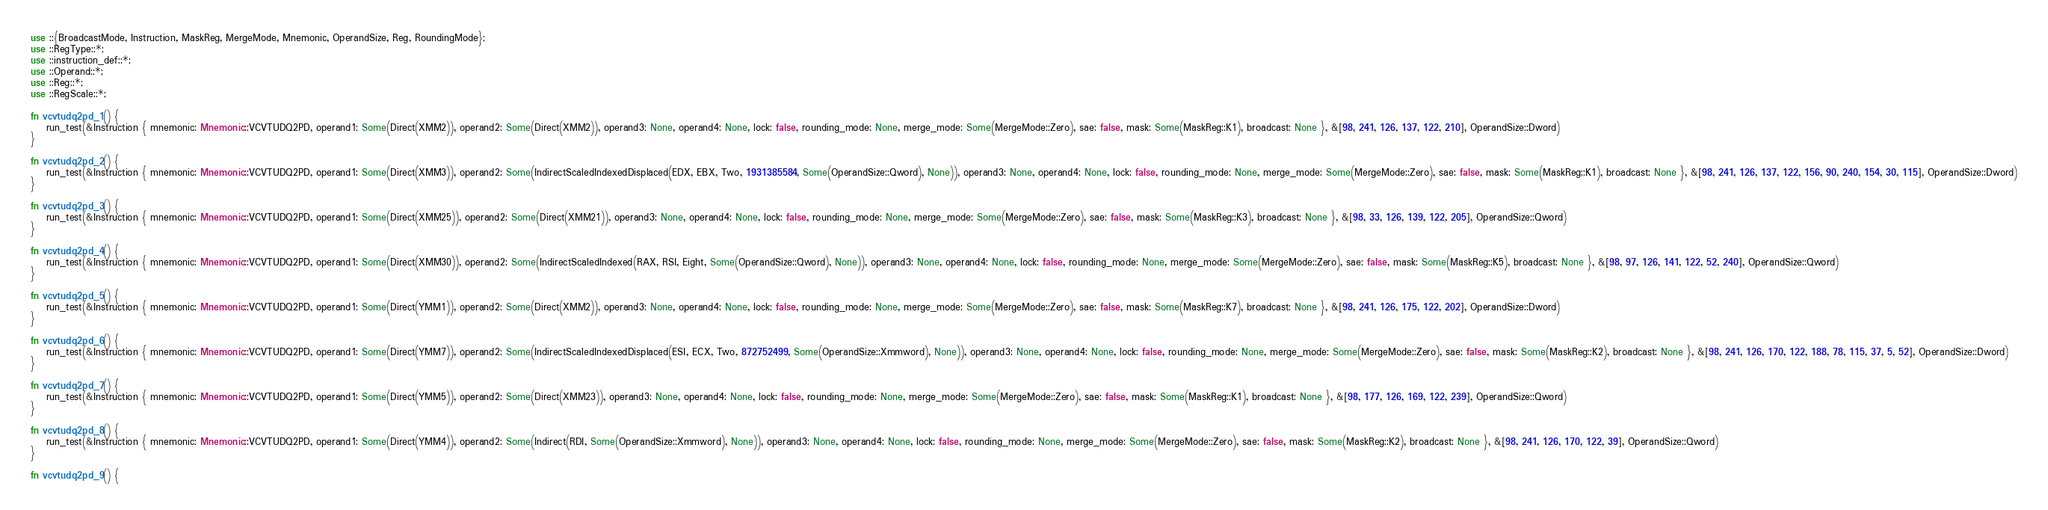Convert code to text. <code><loc_0><loc_0><loc_500><loc_500><_Rust_>use ::{BroadcastMode, Instruction, MaskReg, MergeMode, Mnemonic, OperandSize, Reg, RoundingMode};
use ::RegType::*;
use ::instruction_def::*;
use ::Operand::*;
use ::Reg::*;
use ::RegScale::*;

fn vcvtudq2pd_1() {
    run_test(&Instruction { mnemonic: Mnemonic::VCVTUDQ2PD, operand1: Some(Direct(XMM2)), operand2: Some(Direct(XMM2)), operand3: None, operand4: None, lock: false, rounding_mode: None, merge_mode: Some(MergeMode::Zero), sae: false, mask: Some(MaskReg::K1), broadcast: None }, &[98, 241, 126, 137, 122, 210], OperandSize::Dword)
}

fn vcvtudq2pd_2() {
    run_test(&Instruction { mnemonic: Mnemonic::VCVTUDQ2PD, operand1: Some(Direct(XMM3)), operand2: Some(IndirectScaledIndexedDisplaced(EDX, EBX, Two, 1931385584, Some(OperandSize::Qword), None)), operand3: None, operand4: None, lock: false, rounding_mode: None, merge_mode: Some(MergeMode::Zero), sae: false, mask: Some(MaskReg::K1), broadcast: None }, &[98, 241, 126, 137, 122, 156, 90, 240, 154, 30, 115], OperandSize::Dword)
}

fn vcvtudq2pd_3() {
    run_test(&Instruction { mnemonic: Mnemonic::VCVTUDQ2PD, operand1: Some(Direct(XMM25)), operand2: Some(Direct(XMM21)), operand3: None, operand4: None, lock: false, rounding_mode: None, merge_mode: Some(MergeMode::Zero), sae: false, mask: Some(MaskReg::K3), broadcast: None }, &[98, 33, 126, 139, 122, 205], OperandSize::Qword)
}

fn vcvtudq2pd_4() {
    run_test(&Instruction { mnemonic: Mnemonic::VCVTUDQ2PD, operand1: Some(Direct(XMM30)), operand2: Some(IndirectScaledIndexed(RAX, RSI, Eight, Some(OperandSize::Qword), None)), operand3: None, operand4: None, lock: false, rounding_mode: None, merge_mode: Some(MergeMode::Zero), sae: false, mask: Some(MaskReg::K5), broadcast: None }, &[98, 97, 126, 141, 122, 52, 240], OperandSize::Qword)
}

fn vcvtudq2pd_5() {
    run_test(&Instruction { mnemonic: Mnemonic::VCVTUDQ2PD, operand1: Some(Direct(YMM1)), operand2: Some(Direct(XMM2)), operand3: None, operand4: None, lock: false, rounding_mode: None, merge_mode: Some(MergeMode::Zero), sae: false, mask: Some(MaskReg::K7), broadcast: None }, &[98, 241, 126, 175, 122, 202], OperandSize::Dword)
}

fn vcvtudq2pd_6() {
    run_test(&Instruction { mnemonic: Mnemonic::VCVTUDQ2PD, operand1: Some(Direct(YMM7)), operand2: Some(IndirectScaledIndexedDisplaced(ESI, ECX, Two, 872752499, Some(OperandSize::Xmmword), None)), operand3: None, operand4: None, lock: false, rounding_mode: None, merge_mode: Some(MergeMode::Zero), sae: false, mask: Some(MaskReg::K2), broadcast: None }, &[98, 241, 126, 170, 122, 188, 78, 115, 37, 5, 52], OperandSize::Dword)
}

fn vcvtudq2pd_7() {
    run_test(&Instruction { mnemonic: Mnemonic::VCVTUDQ2PD, operand1: Some(Direct(YMM5)), operand2: Some(Direct(XMM23)), operand3: None, operand4: None, lock: false, rounding_mode: None, merge_mode: Some(MergeMode::Zero), sae: false, mask: Some(MaskReg::K1), broadcast: None }, &[98, 177, 126, 169, 122, 239], OperandSize::Qword)
}

fn vcvtudq2pd_8() {
    run_test(&Instruction { mnemonic: Mnemonic::VCVTUDQ2PD, operand1: Some(Direct(YMM4)), operand2: Some(Indirect(RDI, Some(OperandSize::Xmmword), None)), operand3: None, operand4: None, lock: false, rounding_mode: None, merge_mode: Some(MergeMode::Zero), sae: false, mask: Some(MaskReg::K2), broadcast: None }, &[98, 241, 126, 170, 122, 39], OperandSize::Qword)
}

fn vcvtudq2pd_9() {</code> 